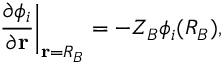<formula> <loc_0><loc_0><loc_500><loc_500>\frac { \partial \phi _ { i } } { \partial r } \Big | _ { r = R _ { B } } = - Z _ { B } \phi _ { i } ( R _ { B } ) ,</formula> 